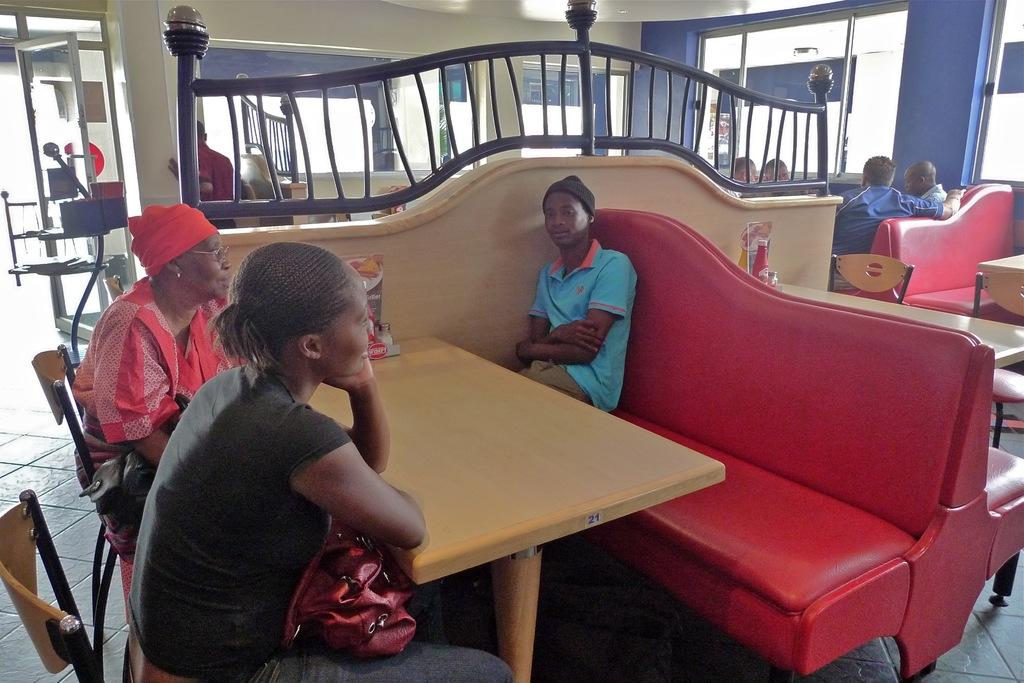How many people are sitting in the image? There are three persons sitting on chairs in the image. What is the main piece of furniture in the image? There is a table in the image. What architectural feature can be seen in the image? There is a pillar in the image. What object is likely used for drinking in the image? There is a glass in the image. What surface is visible beneath the people and furniture? The floor is visible in the image. What type of plant is growing on the table in the image? There is no plant visible on the table in the image. 